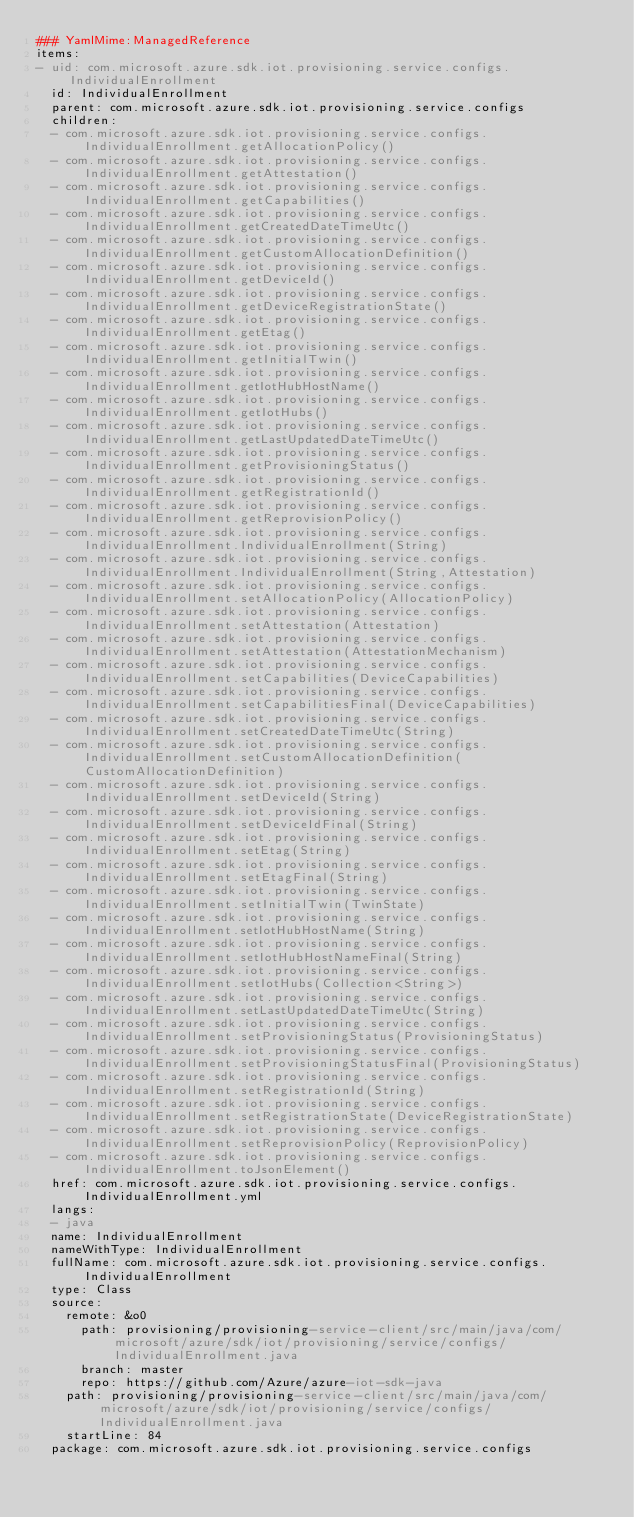<code> <loc_0><loc_0><loc_500><loc_500><_YAML_>### YamlMime:ManagedReference
items:
- uid: com.microsoft.azure.sdk.iot.provisioning.service.configs.IndividualEnrollment
  id: IndividualEnrollment
  parent: com.microsoft.azure.sdk.iot.provisioning.service.configs
  children:
  - com.microsoft.azure.sdk.iot.provisioning.service.configs.IndividualEnrollment.getAllocationPolicy()
  - com.microsoft.azure.sdk.iot.provisioning.service.configs.IndividualEnrollment.getAttestation()
  - com.microsoft.azure.sdk.iot.provisioning.service.configs.IndividualEnrollment.getCapabilities()
  - com.microsoft.azure.sdk.iot.provisioning.service.configs.IndividualEnrollment.getCreatedDateTimeUtc()
  - com.microsoft.azure.sdk.iot.provisioning.service.configs.IndividualEnrollment.getCustomAllocationDefinition()
  - com.microsoft.azure.sdk.iot.provisioning.service.configs.IndividualEnrollment.getDeviceId()
  - com.microsoft.azure.sdk.iot.provisioning.service.configs.IndividualEnrollment.getDeviceRegistrationState()
  - com.microsoft.azure.sdk.iot.provisioning.service.configs.IndividualEnrollment.getEtag()
  - com.microsoft.azure.sdk.iot.provisioning.service.configs.IndividualEnrollment.getInitialTwin()
  - com.microsoft.azure.sdk.iot.provisioning.service.configs.IndividualEnrollment.getIotHubHostName()
  - com.microsoft.azure.sdk.iot.provisioning.service.configs.IndividualEnrollment.getIotHubs()
  - com.microsoft.azure.sdk.iot.provisioning.service.configs.IndividualEnrollment.getLastUpdatedDateTimeUtc()
  - com.microsoft.azure.sdk.iot.provisioning.service.configs.IndividualEnrollment.getProvisioningStatus()
  - com.microsoft.azure.sdk.iot.provisioning.service.configs.IndividualEnrollment.getRegistrationId()
  - com.microsoft.azure.sdk.iot.provisioning.service.configs.IndividualEnrollment.getReprovisionPolicy()
  - com.microsoft.azure.sdk.iot.provisioning.service.configs.IndividualEnrollment.IndividualEnrollment(String)
  - com.microsoft.azure.sdk.iot.provisioning.service.configs.IndividualEnrollment.IndividualEnrollment(String,Attestation)
  - com.microsoft.azure.sdk.iot.provisioning.service.configs.IndividualEnrollment.setAllocationPolicy(AllocationPolicy)
  - com.microsoft.azure.sdk.iot.provisioning.service.configs.IndividualEnrollment.setAttestation(Attestation)
  - com.microsoft.azure.sdk.iot.provisioning.service.configs.IndividualEnrollment.setAttestation(AttestationMechanism)
  - com.microsoft.azure.sdk.iot.provisioning.service.configs.IndividualEnrollment.setCapabilities(DeviceCapabilities)
  - com.microsoft.azure.sdk.iot.provisioning.service.configs.IndividualEnrollment.setCapabilitiesFinal(DeviceCapabilities)
  - com.microsoft.azure.sdk.iot.provisioning.service.configs.IndividualEnrollment.setCreatedDateTimeUtc(String)
  - com.microsoft.azure.sdk.iot.provisioning.service.configs.IndividualEnrollment.setCustomAllocationDefinition(CustomAllocationDefinition)
  - com.microsoft.azure.sdk.iot.provisioning.service.configs.IndividualEnrollment.setDeviceId(String)
  - com.microsoft.azure.sdk.iot.provisioning.service.configs.IndividualEnrollment.setDeviceIdFinal(String)
  - com.microsoft.azure.sdk.iot.provisioning.service.configs.IndividualEnrollment.setEtag(String)
  - com.microsoft.azure.sdk.iot.provisioning.service.configs.IndividualEnrollment.setEtagFinal(String)
  - com.microsoft.azure.sdk.iot.provisioning.service.configs.IndividualEnrollment.setInitialTwin(TwinState)
  - com.microsoft.azure.sdk.iot.provisioning.service.configs.IndividualEnrollment.setIotHubHostName(String)
  - com.microsoft.azure.sdk.iot.provisioning.service.configs.IndividualEnrollment.setIotHubHostNameFinal(String)
  - com.microsoft.azure.sdk.iot.provisioning.service.configs.IndividualEnrollment.setIotHubs(Collection<String>)
  - com.microsoft.azure.sdk.iot.provisioning.service.configs.IndividualEnrollment.setLastUpdatedDateTimeUtc(String)
  - com.microsoft.azure.sdk.iot.provisioning.service.configs.IndividualEnrollment.setProvisioningStatus(ProvisioningStatus)
  - com.microsoft.azure.sdk.iot.provisioning.service.configs.IndividualEnrollment.setProvisioningStatusFinal(ProvisioningStatus)
  - com.microsoft.azure.sdk.iot.provisioning.service.configs.IndividualEnrollment.setRegistrationId(String)
  - com.microsoft.azure.sdk.iot.provisioning.service.configs.IndividualEnrollment.setRegistrationState(DeviceRegistrationState)
  - com.microsoft.azure.sdk.iot.provisioning.service.configs.IndividualEnrollment.setReprovisionPolicy(ReprovisionPolicy)
  - com.microsoft.azure.sdk.iot.provisioning.service.configs.IndividualEnrollment.toJsonElement()
  href: com.microsoft.azure.sdk.iot.provisioning.service.configs.IndividualEnrollment.yml
  langs:
  - java
  name: IndividualEnrollment
  nameWithType: IndividualEnrollment
  fullName: com.microsoft.azure.sdk.iot.provisioning.service.configs.IndividualEnrollment
  type: Class
  source:
    remote: &o0
      path: provisioning/provisioning-service-client/src/main/java/com/microsoft/azure/sdk/iot/provisioning/service/configs/IndividualEnrollment.java
      branch: master
      repo: https://github.com/Azure/azure-iot-sdk-java
    path: provisioning/provisioning-service-client/src/main/java/com/microsoft/azure/sdk/iot/provisioning/service/configs/IndividualEnrollment.java
    startLine: 84
  package: com.microsoft.azure.sdk.iot.provisioning.service.configs</code> 